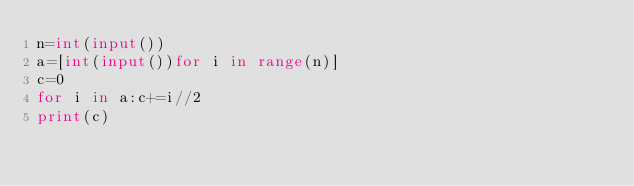<code> <loc_0><loc_0><loc_500><loc_500><_Python_>n=int(input())
a=[int(input())for i in range(n)]
c=0
for i in a:c+=i//2
print(c)</code> 